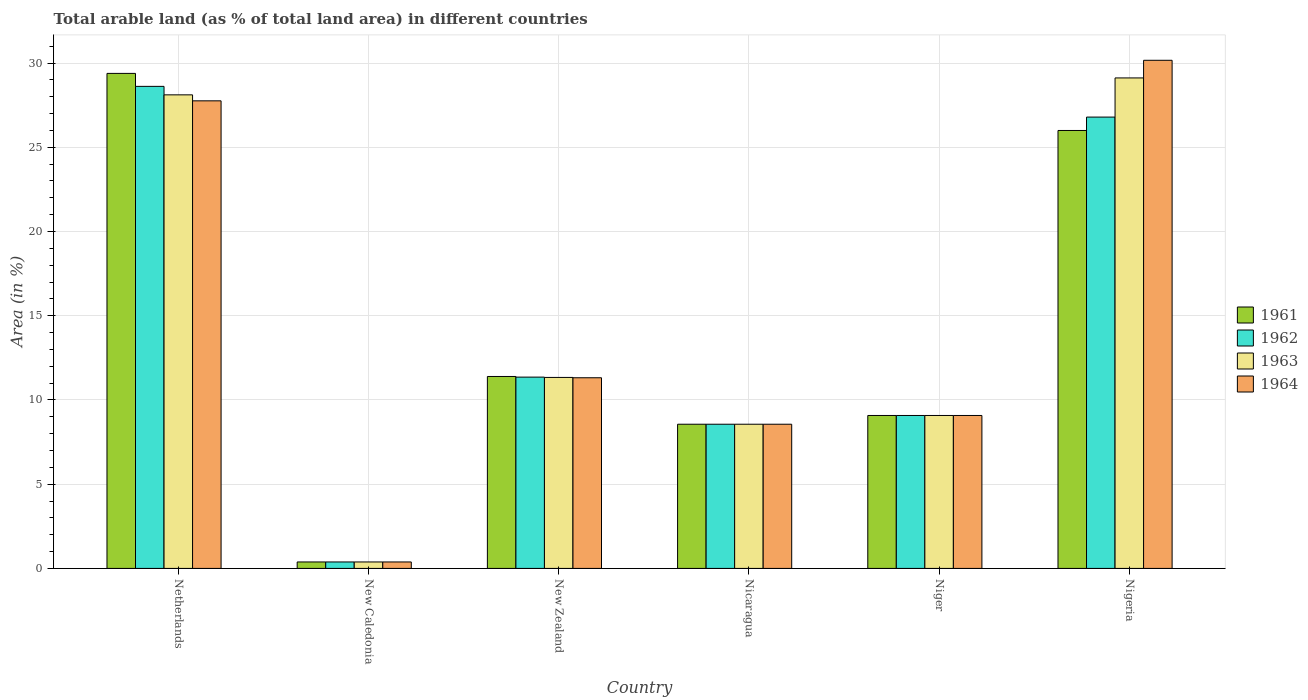How many different coloured bars are there?
Provide a succinct answer. 4. Are the number of bars per tick equal to the number of legend labels?
Your answer should be compact. Yes. Are the number of bars on each tick of the X-axis equal?
Offer a very short reply. Yes. How many bars are there on the 2nd tick from the left?
Offer a very short reply. 4. What is the label of the 6th group of bars from the left?
Your answer should be compact. Nigeria. What is the percentage of arable land in 1964 in New Zealand?
Ensure brevity in your answer.  11.32. Across all countries, what is the maximum percentage of arable land in 1961?
Offer a very short reply. 29.38. Across all countries, what is the minimum percentage of arable land in 1964?
Keep it short and to the point. 0.38. In which country was the percentage of arable land in 1963 maximum?
Offer a very short reply. Nigeria. In which country was the percentage of arable land in 1961 minimum?
Offer a very short reply. New Caledonia. What is the total percentage of arable land in 1963 in the graph?
Keep it short and to the point. 86.58. What is the difference between the percentage of arable land in 1964 in Nicaragua and that in Niger?
Your answer should be very brief. -0.52. What is the difference between the percentage of arable land in 1962 in Niger and the percentage of arable land in 1964 in New Caledonia?
Your answer should be very brief. 8.69. What is the average percentage of arable land in 1963 per country?
Your answer should be compact. 14.43. In how many countries, is the percentage of arable land in 1964 greater than 17 %?
Provide a short and direct response. 2. What is the ratio of the percentage of arable land in 1962 in Nicaragua to that in Nigeria?
Keep it short and to the point. 0.32. What is the difference between the highest and the second highest percentage of arable land in 1963?
Provide a short and direct response. -16.77. What is the difference between the highest and the lowest percentage of arable land in 1964?
Provide a succinct answer. 29.78. In how many countries, is the percentage of arable land in 1961 greater than the average percentage of arable land in 1961 taken over all countries?
Your response must be concise. 2. Is it the case that in every country, the sum of the percentage of arable land in 1962 and percentage of arable land in 1963 is greater than the sum of percentage of arable land in 1964 and percentage of arable land in 1961?
Offer a terse response. No. What does the 2nd bar from the right in Netherlands represents?
Provide a short and direct response. 1963. How many bars are there?
Provide a short and direct response. 24. Are all the bars in the graph horizontal?
Provide a short and direct response. No. How many countries are there in the graph?
Give a very brief answer. 6. Does the graph contain any zero values?
Offer a terse response. No. Where does the legend appear in the graph?
Ensure brevity in your answer.  Center right. What is the title of the graph?
Your response must be concise. Total arable land (as % of total land area) in different countries. Does "2011" appear as one of the legend labels in the graph?
Your answer should be compact. No. What is the label or title of the X-axis?
Make the answer very short. Country. What is the label or title of the Y-axis?
Your answer should be compact. Area (in %). What is the Area (in %) of 1961 in Netherlands?
Offer a very short reply. 29.38. What is the Area (in %) of 1962 in Netherlands?
Keep it short and to the point. 28.61. What is the Area (in %) in 1963 in Netherlands?
Your answer should be very brief. 28.11. What is the Area (in %) of 1964 in Netherlands?
Offer a terse response. 27.75. What is the Area (in %) in 1961 in New Caledonia?
Offer a terse response. 0.38. What is the Area (in %) in 1962 in New Caledonia?
Your answer should be very brief. 0.38. What is the Area (in %) of 1963 in New Caledonia?
Provide a short and direct response. 0.38. What is the Area (in %) of 1964 in New Caledonia?
Ensure brevity in your answer.  0.38. What is the Area (in %) of 1961 in New Zealand?
Give a very brief answer. 11.39. What is the Area (in %) in 1962 in New Zealand?
Keep it short and to the point. 11.36. What is the Area (in %) of 1963 in New Zealand?
Make the answer very short. 11.34. What is the Area (in %) of 1964 in New Zealand?
Your answer should be very brief. 11.32. What is the Area (in %) in 1961 in Nicaragua?
Offer a very short reply. 8.56. What is the Area (in %) of 1962 in Nicaragua?
Provide a succinct answer. 8.56. What is the Area (in %) in 1963 in Nicaragua?
Ensure brevity in your answer.  8.56. What is the Area (in %) in 1964 in Nicaragua?
Offer a very short reply. 8.56. What is the Area (in %) of 1961 in Niger?
Offer a terse response. 9.08. What is the Area (in %) of 1962 in Niger?
Make the answer very short. 9.08. What is the Area (in %) in 1963 in Niger?
Offer a terse response. 9.08. What is the Area (in %) of 1964 in Niger?
Give a very brief answer. 9.08. What is the Area (in %) of 1961 in Nigeria?
Your answer should be very brief. 26. What is the Area (in %) in 1962 in Nigeria?
Provide a short and direct response. 26.79. What is the Area (in %) in 1963 in Nigeria?
Offer a very short reply. 29.11. What is the Area (in %) in 1964 in Nigeria?
Provide a short and direct response. 30.16. Across all countries, what is the maximum Area (in %) of 1961?
Offer a terse response. 29.38. Across all countries, what is the maximum Area (in %) in 1962?
Your answer should be compact. 28.61. Across all countries, what is the maximum Area (in %) of 1963?
Provide a succinct answer. 29.11. Across all countries, what is the maximum Area (in %) in 1964?
Make the answer very short. 30.16. Across all countries, what is the minimum Area (in %) in 1961?
Offer a terse response. 0.38. Across all countries, what is the minimum Area (in %) of 1962?
Offer a very short reply. 0.38. Across all countries, what is the minimum Area (in %) of 1963?
Your answer should be compact. 0.38. Across all countries, what is the minimum Area (in %) of 1964?
Your response must be concise. 0.38. What is the total Area (in %) of 1961 in the graph?
Ensure brevity in your answer.  84.79. What is the total Area (in %) in 1962 in the graph?
Keep it short and to the point. 84.78. What is the total Area (in %) in 1963 in the graph?
Offer a terse response. 86.58. What is the total Area (in %) of 1964 in the graph?
Ensure brevity in your answer.  87.25. What is the difference between the Area (in %) of 1961 in Netherlands and that in New Caledonia?
Keep it short and to the point. 29. What is the difference between the Area (in %) in 1962 in Netherlands and that in New Caledonia?
Offer a very short reply. 28.23. What is the difference between the Area (in %) in 1963 in Netherlands and that in New Caledonia?
Give a very brief answer. 27.73. What is the difference between the Area (in %) of 1964 in Netherlands and that in New Caledonia?
Your answer should be compact. 27.37. What is the difference between the Area (in %) in 1961 in Netherlands and that in New Zealand?
Make the answer very short. 17.99. What is the difference between the Area (in %) of 1962 in Netherlands and that in New Zealand?
Provide a short and direct response. 17.26. What is the difference between the Area (in %) of 1963 in Netherlands and that in New Zealand?
Ensure brevity in your answer.  16.77. What is the difference between the Area (in %) in 1964 in Netherlands and that in New Zealand?
Make the answer very short. 16.44. What is the difference between the Area (in %) in 1961 in Netherlands and that in Nicaragua?
Your response must be concise. 20.82. What is the difference between the Area (in %) of 1962 in Netherlands and that in Nicaragua?
Your answer should be compact. 20.05. What is the difference between the Area (in %) of 1963 in Netherlands and that in Nicaragua?
Make the answer very short. 19.55. What is the difference between the Area (in %) in 1964 in Netherlands and that in Nicaragua?
Make the answer very short. 19.2. What is the difference between the Area (in %) in 1961 in Netherlands and that in Niger?
Offer a very short reply. 20.31. What is the difference between the Area (in %) of 1962 in Netherlands and that in Niger?
Your response must be concise. 19.54. What is the difference between the Area (in %) of 1963 in Netherlands and that in Niger?
Offer a terse response. 19.03. What is the difference between the Area (in %) of 1964 in Netherlands and that in Niger?
Give a very brief answer. 18.68. What is the difference between the Area (in %) of 1961 in Netherlands and that in Nigeria?
Give a very brief answer. 3.39. What is the difference between the Area (in %) of 1962 in Netherlands and that in Nigeria?
Make the answer very short. 1.82. What is the difference between the Area (in %) of 1963 in Netherlands and that in Nigeria?
Offer a terse response. -1. What is the difference between the Area (in %) in 1964 in Netherlands and that in Nigeria?
Your answer should be compact. -2.41. What is the difference between the Area (in %) of 1961 in New Caledonia and that in New Zealand?
Offer a very short reply. -11.01. What is the difference between the Area (in %) in 1962 in New Caledonia and that in New Zealand?
Provide a short and direct response. -10.97. What is the difference between the Area (in %) in 1963 in New Caledonia and that in New Zealand?
Make the answer very short. -10.95. What is the difference between the Area (in %) in 1964 in New Caledonia and that in New Zealand?
Give a very brief answer. -10.93. What is the difference between the Area (in %) of 1961 in New Caledonia and that in Nicaragua?
Ensure brevity in your answer.  -8.18. What is the difference between the Area (in %) in 1962 in New Caledonia and that in Nicaragua?
Your response must be concise. -8.18. What is the difference between the Area (in %) of 1963 in New Caledonia and that in Nicaragua?
Keep it short and to the point. -8.18. What is the difference between the Area (in %) in 1964 in New Caledonia and that in Nicaragua?
Make the answer very short. -8.18. What is the difference between the Area (in %) of 1961 in New Caledonia and that in Niger?
Offer a terse response. -8.7. What is the difference between the Area (in %) in 1962 in New Caledonia and that in Niger?
Your response must be concise. -8.7. What is the difference between the Area (in %) in 1963 in New Caledonia and that in Niger?
Keep it short and to the point. -8.7. What is the difference between the Area (in %) in 1964 in New Caledonia and that in Niger?
Offer a terse response. -8.7. What is the difference between the Area (in %) in 1961 in New Caledonia and that in Nigeria?
Your response must be concise. -25.61. What is the difference between the Area (in %) of 1962 in New Caledonia and that in Nigeria?
Keep it short and to the point. -26.41. What is the difference between the Area (in %) in 1963 in New Caledonia and that in Nigeria?
Your answer should be very brief. -28.73. What is the difference between the Area (in %) in 1964 in New Caledonia and that in Nigeria?
Your response must be concise. -29.78. What is the difference between the Area (in %) of 1961 in New Zealand and that in Nicaragua?
Offer a terse response. 2.83. What is the difference between the Area (in %) of 1962 in New Zealand and that in Nicaragua?
Keep it short and to the point. 2.8. What is the difference between the Area (in %) of 1963 in New Zealand and that in Nicaragua?
Provide a succinct answer. 2.78. What is the difference between the Area (in %) in 1964 in New Zealand and that in Nicaragua?
Offer a terse response. 2.76. What is the difference between the Area (in %) of 1961 in New Zealand and that in Niger?
Your response must be concise. 2.32. What is the difference between the Area (in %) of 1962 in New Zealand and that in Niger?
Keep it short and to the point. 2.28. What is the difference between the Area (in %) of 1963 in New Zealand and that in Niger?
Provide a short and direct response. 2.26. What is the difference between the Area (in %) of 1964 in New Zealand and that in Niger?
Offer a terse response. 2.24. What is the difference between the Area (in %) in 1961 in New Zealand and that in Nigeria?
Give a very brief answer. -14.6. What is the difference between the Area (in %) in 1962 in New Zealand and that in Nigeria?
Offer a very short reply. -15.44. What is the difference between the Area (in %) of 1963 in New Zealand and that in Nigeria?
Make the answer very short. -17.78. What is the difference between the Area (in %) in 1964 in New Zealand and that in Nigeria?
Your response must be concise. -18.84. What is the difference between the Area (in %) of 1961 in Nicaragua and that in Niger?
Your answer should be compact. -0.52. What is the difference between the Area (in %) in 1962 in Nicaragua and that in Niger?
Provide a short and direct response. -0.52. What is the difference between the Area (in %) of 1963 in Nicaragua and that in Niger?
Give a very brief answer. -0.52. What is the difference between the Area (in %) in 1964 in Nicaragua and that in Niger?
Offer a terse response. -0.52. What is the difference between the Area (in %) in 1961 in Nicaragua and that in Nigeria?
Give a very brief answer. -17.44. What is the difference between the Area (in %) of 1962 in Nicaragua and that in Nigeria?
Offer a terse response. -18.23. What is the difference between the Area (in %) of 1963 in Nicaragua and that in Nigeria?
Ensure brevity in your answer.  -20.56. What is the difference between the Area (in %) in 1964 in Nicaragua and that in Nigeria?
Your answer should be very brief. -21.6. What is the difference between the Area (in %) of 1961 in Niger and that in Nigeria?
Your answer should be compact. -16.92. What is the difference between the Area (in %) in 1962 in Niger and that in Nigeria?
Give a very brief answer. -17.71. What is the difference between the Area (in %) in 1963 in Niger and that in Nigeria?
Your answer should be compact. -20.04. What is the difference between the Area (in %) in 1964 in Niger and that in Nigeria?
Provide a succinct answer. -21.08. What is the difference between the Area (in %) in 1961 in Netherlands and the Area (in %) in 1962 in New Caledonia?
Provide a short and direct response. 29. What is the difference between the Area (in %) in 1961 in Netherlands and the Area (in %) in 1963 in New Caledonia?
Provide a short and direct response. 29. What is the difference between the Area (in %) in 1961 in Netherlands and the Area (in %) in 1964 in New Caledonia?
Your answer should be compact. 29. What is the difference between the Area (in %) of 1962 in Netherlands and the Area (in %) of 1963 in New Caledonia?
Your response must be concise. 28.23. What is the difference between the Area (in %) of 1962 in Netherlands and the Area (in %) of 1964 in New Caledonia?
Ensure brevity in your answer.  28.23. What is the difference between the Area (in %) in 1963 in Netherlands and the Area (in %) in 1964 in New Caledonia?
Provide a succinct answer. 27.73. What is the difference between the Area (in %) in 1961 in Netherlands and the Area (in %) in 1962 in New Zealand?
Your answer should be very brief. 18.03. What is the difference between the Area (in %) in 1961 in Netherlands and the Area (in %) in 1963 in New Zealand?
Offer a terse response. 18.05. What is the difference between the Area (in %) of 1961 in Netherlands and the Area (in %) of 1964 in New Zealand?
Provide a succinct answer. 18.07. What is the difference between the Area (in %) in 1962 in Netherlands and the Area (in %) in 1963 in New Zealand?
Offer a very short reply. 17.28. What is the difference between the Area (in %) of 1962 in Netherlands and the Area (in %) of 1964 in New Zealand?
Give a very brief answer. 17.3. What is the difference between the Area (in %) of 1963 in Netherlands and the Area (in %) of 1964 in New Zealand?
Make the answer very short. 16.79. What is the difference between the Area (in %) of 1961 in Netherlands and the Area (in %) of 1962 in Nicaragua?
Your answer should be very brief. 20.82. What is the difference between the Area (in %) in 1961 in Netherlands and the Area (in %) in 1963 in Nicaragua?
Make the answer very short. 20.82. What is the difference between the Area (in %) in 1961 in Netherlands and the Area (in %) in 1964 in Nicaragua?
Keep it short and to the point. 20.82. What is the difference between the Area (in %) of 1962 in Netherlands and the Area (in %) of 1963 in Nicaragua?
Ensure brevity in your answer.  20.05. What is the difference between the Area (in %) in 1962 in Netherlands and the Area (in %) in 1964 in Nicaragua?
Ensure brevity in your answer.  20.05. What is the difference between the Area (in %) of 1963 in Netherlands and the Area (in %) of 1964 in Nicaragua?
Offer a terse response. 19.55. What is the difference between the Area (in %) of 1961 in Netherlands and the Area (in %) of 1962 in Niger?
Provide a succinct answer. 20.31. What is the difference between the Area (in %) in 1961 in Netherlands and the Area (in %) in 1963 in Niger?
Offer a very short reply. 20.31. What is the difference between the Area (in %) of 1961 in Netherlands and the Area (in %) of 1964 in Niger?
Provide a succinct answer. 20.31. What is the difference between the Area (in %) in 1962 in Netherlands and the Area (in %) in 1963 in Niger?
Offer a terse response. 19.54. What is the difference between the Area (in %) of 1962 in Netherlands and the Area (in %) of 1964 in Niger?
Provide a succinct answer. 19.54. What is the difference between the Area (in %) in 1963 in Netherlands and the Area (in %) in 1964 in Niger?
Your response must be concise. 19.03. What is the difference between the Area (in %) of 1961 in Netherlands and the Area (in %) of 1962 in Nigeria?
Offer a terse response. 2.59. What is the difference between the Area (in %) of 1961 in Netherlands and the Area (in %) of 1963 in Nigeria?
Offer a terse response. 0.27. What is the difference between the Area (in %) in 1961 in Netherlands and the Area (in %) in 1964 in Nigeria?
Your response must be concise. -0.78. What is the difference between the Area (in %) of 1962 in Netherlands and the Area (in %) of 1963 in Nigeria?
Provide a short and direct response. -0.5. What is the difference between the Area (in %) in 1962 in Netherlands and the Area (in %) in 1964 in Nigeria?
Ensure brevity in your answer.  -1.55. What is the difference between the Area (in %) of 1963 in Netherlands and the Area (in %) of 1964 in Nigeria?
Your answer should be compact. -2.05. What is the difference between the Area (in %) of 1961 in New Caledonia and the Area (in %) of 1962 in New Zealand?
Your answer should be very brief. -10.97. What is the difference between the Area (in %) of 1961 in New Caledonia and the Area (in %) of 1963 in New Zealand?
Your answer should be very brief. -10.95. What is the difference between the Area (in %) in 1961 in New Caledonia and the Area (in %) in 1964 in New Zealand?
Provide a short and direct response. -10.93. What is the difference between the Area (in %) of 1962 in New Caledonia and the Area (in %) of 1963 in New Zealand?
Your response must be concise. -10.95. What is the difference between the Area (in %) in 1962 in New Caledonia and the Area (in %) in 1964 in New Zealand?
Keep it short and to the point. -10.93. What is the difference between the Area (in %) in 1963 in New Caledonia and the Area (in %) in 1964 in New Zealand?
Make the answer very short. -10.93. What is the difference between the Area (in %) of 1961 in New Caledonia and the Area (in %) of 1962 in Nicaragua?
Keep it short and to the point. -8.18. What is the difference between the Area (in %) in 1961 in New Caledonia and the Area (in %) in 1963 in Nicaragua?
Ensure brevity in your answer.  -8.18. What is the difference between the Area (in %) of 1961 in New Caledonia and the Area (in %) of 1964 in Nicaragua?
Provide a short and direct response. -8.18. What is the difference between the Area (in %) of 1962 in New Caledonia and the Area (in %) of 1963 in Nicaragua?
Ensure brevity in your answer.  -8.18. What is the difference between the Area (in %) of 1962 in New Caledonia and the Area (in %) of 1964 in Nicaragua?
Ensure brevity in your answer.  -8.18. What is the difference between the Area (in %) of 1963 in New Caledonia and the Area (in %) of 1964 in Nicaragua?
Keep it short and to the point. -8.18. What is the difference between the Area (in %) of 1961 in New Caledonia and the Area (in %) of 1962 in Niger?
Ensure brevity in your answer.  -8.7. What is the difference between the Area (in %) in 1961 in New Caledonia and the Area (in %) in 1963 in Niger?
Keep it short and to the point. -8.7. What is the difference between the Area (in %) in 1961 in New Caledonia and the Area (in %) in 1964 in Niger?
Offer a terse response. -8.7. What is the difference between the Area (in %) in 1962 in New Caledonia and the Area (in %) in 1963 in Niger?
Offer a terse response. -8.7. What is the difference between the Area (in %) in 1962 in New Caledonia and the Area (in %) in 1964 in Niger?
Make the answer very short. -8.7. What is the difference between the Area (in %) of 1963 in New Caledonia and the Area (in %) of 1964 in Niger?
Provide a short and direct response. -8.7. What is the difference between the Area (in %) of 1961 in New Caledonia and the Area (in %) of 1962 in Nigeria?
Provide a short and direct response. -26.41. What is the difference between the Area (in %) in 1961 in New Caledonia and the Area (in %) in 1963 in Nigeria?
Give a very brief answer. -28.73. What is the difference between the Area (in %) of 1961 in New Caledonia and the Area (in %) of 1964 in Nigeria?
Make the answer very short. -29.78. What is the difference between the Area (in %) in 1962 in New Caledonia and the Area (in %) in 1963 in Nigeria?
Offer a very short reply. -28.73. What is the difference between the Area (in %) of 1962 in New Caledonia and the Area (in %) of 1964 in Nigeria?
Your answer should be very brief. -29.78. What is the difference between the Area (in %) in 1963 in New Caledonia and the Area (in %) in 1964 in Nigeria?
Your answer should be compact. -29.78. What is the difference between the Area (in %) in 1961 in New Zealand and the Area (in %) in 1962 in Nicaragua?
Give a very brief answer. 2.83. What is the difference between the Area (in %) in 1961 in New Zealand and the Area (in %) in 1963 in Nicaragua?
Offer a terse response. 2.83. What is the difference between the Area (in %) of 1961 in New Zealand and the Area (in %) of 1964 in Nicaragua?
Your answer should be compact. 2.83. What is the difference between the Area (in %) of 1962 in New Zealand and the Area (in %) of 1963 in Nicaragua?
Your response must be concise. 2.8. What is the difference between the Area (in %) in 1962 in New Zealand and the Area (in %) in 1964 in Nicaragua?
Your response must be concise. 2.8. What is the difference between the Area (in %) in 1963 in New Zealand and the Area (in %) in 1964 in Nicaragua?
Provide a short and direct response. 2.78. What is the difference between the Area (in %) in 1961 in New Zealand and the Area (in %) in 1962 in Niger?
Offer a very short reply. 2.32. What is the difference between the Area (in %) of 1961 in New Zealand and the Area (in %) of 1963 in Niger?
Offer a very short reply. 2.32. What is the difference between the Area (in %) of 1961 in New Zealand and the Area (in %) of 1964 in Niger?
Your answer should be compact. 2.32. What is the difference between the Area (in %) of 1962 in New Zealand and the Area (in %) of 1963 in Niger?
Make the answer very short. 2.28. What is the difference between the Area (in %) of 1962 in New Zealand and the Area (in %) of 1964 in Niger?
Provide a succinct answer. 2.28. What is the difference between the Area (in %) in 1963 in New Zealand and the Area (in %) in 1964 in Niger?
Ensure brevity in your answer.  2.26. What is the difference between the Area (in %) of 1961 in New Zealand and the Area (in %) of 1962 in Nigeria?
Offer a terse response. -15.4. What is the difference between the Area (in %) in 1961 in New Zealand and the Area (in %) in 1963 in Nigeria?
Provide a short and direct response. -17.72. What is the difference between the Area (in %) of 1961 in New Zealand and the Area (in %) of 1964 in Nigeria?
Offer a very short reply. -18.77. What is the difference between the Area (in %) in 1962 in New Zealand and the Area (in %) in 1963 in Nigeria?
Provide a succinct answer. -17.76. What is the difference between the Area (in %) in 1962 in New Zealand and the Area (in %) in 1964 in Nigeria?
Your response must be concise. -18.81. What is the difference between the Area (in %) in 1963 in New Zealand and the Area (in %) in 1964 in Nigeria?
Keep it short and to the point. -18.83. What is the difference between the Area (in %) in 1961 in Nicaragua and the Area (in %) in 1962 in Niger?
Provide a short and direct response. -0.52. What is the difference between the Area (in %) of 1961 in Nicaragua and the Area (in %) of 1963 in Niger?
Your answer should be compact. -0.52. What is the difference between the Area (in %) in 1961 in Nicaragua and the Area (in %) in 1964 in Niger?
Provide a succinct answer. -0.52. What is the difference between the Area (in %) in 1962 in Nicaragua and the Area (in %) in 1963 in Niger?
Ensure brevity in your answer.  -0.52. What is the difference between the Area (in %) of 1962 in Nicaragua and the Area (in %) of 1964 in Niger?
Your answer should be compact. -0.52. What is the difference between the Area (in %) of 1963 in Nicaragua and the Area (in %) of 1964 in Niger?
Give a very brief answer. -0.52. What is the difference between the Area (in %) in 1961 in Nicaragua and the Area (in %) in 1962 in Nigeria?
Ensure brevity in your answer.  -18.23. What is the difference between the Area (in %) of 1961 in Nicaragua and the Area (in %) of 1963 in Nigeria?
Make the answer very short. -20.56. What is the difference between the Area (in %) of 1961 in Nicaragua and the Area (in %) of 1964 in Nigeria?
Give a very brief answer. -21.6. What is the difference between the Area (in %) of 1962 in Nicaragua and the Area (in %) of 1963 in Nigeria?
Your response must be concise. -20.56. What is the difference between the Area (in %) of 1962 in Nicaragua and the Area (in %) of 1964 in Nigeria?
Make the answer very short. -21.6. What is the difference between the Area (in %) of 1963 in Nicaragua and the Area (in %) of 1964 in Nigeria?
Provide a short and direct response. -21.6. What is the difference between the Area (in %) of 1961 in Niger and the Area (in %) of 1962 in Nigeria?
Provide a short and direct response. -17.71. What is the difference between the Area (in %) in 1961 in Niger and the Area (in %) in 1963 in Nigeria?
Offer a terse response. -20.04. What is the difference between the Area (in %) of 1961 in Niger and the Area (in %) of 1964 in Nigeria?
Provide a short and direct response. -21.08. What is the difference between the Area (in %) of 1962 in Niger and the Area (in %) of 1963 in Nigeria?
Your response must be concise. -20.04. What is the difference between the Area (in %) in 1962 in Niger and the Area (in %) in 1964 in Nigeria?
Your answer should be compact. -21.08. What is the difference between the Area (in %) in 1963 in Niger and the Area (in %) in 1964 in Nigeria?
Ensure brevity in your answer.  -21.08. What is the average Area (in %) in 1961 per country?
Offer a terse response. 14.13. What is the average Area (in %) of 1962 per country?
Offer a terse response. 14.13. What is the average Area (in %) in 1963 per country?
Your answer should be very brief. 14.43. What is the average Area (in %) in 1964 per country?
Keep it short and to the point. 14.54. What is the difference between the Area (in %) in 1961 and Area (in %) in 1962 in Netherlands?
Your answer should be compact. 0.77. What is the difference between the Area (in %) of 1961 and Area (in %) of 1963 in Netherlands?
Provide a short and direct response. 1.27. What is the difference between the Area (in %) of 1961 and Area (in %) of 1964 in Netherlands?
Offer a terse response. 1.63. What is the difference between the Area (in %) in 1962 and Area (in %) in 1963 in Netherlands?
Make the answer very short. 0.5. What is the difference between the Area (in %) in 1962 and Area (in %) in 1964 in Netherlands?
Your response must be concise. 0.86. What is the difference between the Area (in %) in 1963 and Area (in %) in 1964 in Netherlands?
Provide a short and direct response. 0.36. What is the difference between the Area (in %) of 1963 and Area (in %) of 1964 in New Caledonia?
Make the answer very short. 0. What is the difference between the Area (in %) in 1961 and Area (in %) in 1962 in New Zealand?
Your answer should be compact. 0.04. What is the difference between the Area (in %) in 1961 and Area (in %) in 1963 in New Zealand?
Your answer should be compact. 0.06. What is the difference between the Area (in %) of 1961 and Area (in %) of 1964 in New Zealand?
Offer a terse response. 0.08. What is the difference between the Area (in %) of 1962 and Area (in %) of 1963 in New Zealand?
Your answer should be very brief. 0.02. What is the difference between the Area (in %) in 1962 and Area (in %) in 1964 in New Zealand?
Provide a succinct answer. 0.04. What is the difference between the Area (in %) of 1963 and Area (in %) of 1964 in New Zealand?
Provide a short and direct response. 0.02. What is the difference between the Area (in %) of 1961 and Area (in %) of 1962 in Nicaragua?
Your answer should be very brief. 0. What is the difference between the Area (in %) of 1961 and Area (in %) of 1963 in Nicaragua?
Offer a terse response. 0. What is the difference between the Area (in %) of 1962 and Area (in %) of 1963 in Nicaragua?
Keep it short and to the point. 0. What is the difference between the Area (in %) in 1962 and Area (in %) in 1964 in Nicaragua?
Your answer should be compact. 0. What is the difference between the Area (in %) in 1963 and Area (in %) in 1964 in Nicaragua?
Offer a very short reply. 0. What is the difference between the Area (in %) in 1961 and Area (in %) in 1962 in Niger?
Provide a short and direct response. 0. What is the difference between the Area (in %) in 1961 and Area (in %) in 1963 in Niger?
Your answer should be very brief. 0. What is the difference between the Area (in %) in 1962 and Area (in %) in 1963 in Niger?
Make the answer very short. 0. What is the difference between the Area (in %) of 1963 and Area (in %) of 1964 in Niger?
Give a very brief answer. 0. What is the difference between the Area (in %) in 1961 and Area (in %) in 1962 in Nigeria?
Your response must be concise. -0.79. What is the difference between the Area (in %) of 1961 and Area (in %) of 1963 in Nigeria?
Make the answer very short. -3.12. What is the difference between the Area (in %) in 1961 and Area (in %) in 1964 in Nigeria?
Offer a very short reply. -4.17. What is the difference between the Area (in %) in 1962 and Area (in %) in 1963 in Nigeria?
Ensure brevity in your answer.  -2.32. What is the difference between the Area (in %) in 1962 and Area (in %) in 1964 in Nigeria?
Your answer should be very brief. -3.37. What is the difference between the Area (in %) in 1963 and Area (in %) in 1964 in Nigeria?
Provide a succinct answer. -1.05. What is the ratio of the Area (in %) in 1961 in Netherlands to that in New Caledonia?
Offer a very short reply. 76.73. What is the ratio of the Area (in %) of 1962 in Netherlands to that in New Caledonia?
Ensure brevity in your answer.  74.72. What is the ratio of the Area (in %) in 1963 in Netherlands to that in New Caledonia?
Give a very brief answer. 73.41. What is the ratio of the Area (in %) in 1964 in Netherlands to that in New Caledonia?
Give a very brief answer. 72.48. What is the ratio of the Area (in %) in 1961 in Netherlands to that in New Zealand?
Provide a succinct answer. 2.58. What is the ratio of the Area (in %) of 1962 in Netherlands to that in New Zealand?
Provide a succinct answer. 2.52. What is the ratio of the Area (in %) in 1963 in Netherlands to that in New Zealand?
Offer a very short reply. 2.48. What is the ratio of the Area (in %) of 1964 in Netherlands to that in New Zealand?
Give a very brief answer. 2.45. What is the ratio of the Area (in %) of 1961 in Netherlands to that in Nicaragua?
Provide a succinct answer. 3.43. What is the ratio of the Area (in %) in 1962 in Netherlands to that in Nicaragua?
Your response must be concise. 3.34. What is the ratio of the Area (in %) in 1963 in Netherlands to that in Nicaragua?
Ensure brevity in your answer.  3.28. What is the ratio of the Area (in %) in 1964 in Netherlands to that in Nicaragua?
Make the answer very short. 3.24. What is the ratio of the Area (in %) in 1961 in Netherlands to that in Niger?
Your response must be concise. 3.24. What is the ratio of the Area (in %) of 1962 in Netherlands to that in Niger?
Give a very brief answer. 3.15. What is the ratio of the Area (in %) in 1963 in Netherlands to that in Niger?
Provide a short and direct response. 3.1. What is the ratio of the Area (in %) in 1964 in Netherlands to that in Niger?
Your answer should be compact. 3.06. What is the ratio of the Area (in %) in 1961 in Netherlands to that in Nigeria?
Your response must be concise. 1.13. What is the ratio of the Area (in %) in 1962 in Netherlands to that in Nigeria?
Ensure brevity in your answer.  1.07. What is the ratio of the Area (in %) of 1963 in Netherlands to that in Nigeria?
Provide a short and direct response. 0.97. What is the ratio of the Area (in %) in 1964 in Netherlands to that in Nigeria?
Your response must be concise. 0.92. What is the ratio of the Area (in %) of 1961 in New Caledonia to that in New Zealand?
Offer a very short reply. 0.03. What is the ratio of the Area (in %) of 1962 in New Caledonia to that in New Zealand?
Your answer should be compact. 0.03. What is the ratio of the Area (in %) in 1963 in New Caledonia to that in New Zealand?
Your answer should be very brief. 0.03. What is the ratio of the Area (in %) of 1964 in New Caledonia to that in New Zealand?
Offer a very short reply. 0.03. What is the ratio of the Area (in %) in 1961 in New Caledonia to that in Nicaragua?
Give a very brief answer. 0.04. What is the ratio of the Area (in %) of 1962 in New Caledonia to that in Nicaragua?
Your answer should be compact. 0.04. What is the ratio of the Area (in %) of 1963 in New Caledonia to that in Nicaragua?
Provide a succinct answer. 0.04. What is the ratio of the Area (in %) in 1964 in New Caledonia to that in Nicaragua?
Your answer should be compact. 0.04. What is the ratio of the Area (in %) in 1961 in New Caledonia to that in Niger?
Ensure brevity in your answer.  0.04. What is the ratio of the Area (in %) of 1962 in New Caledonia to that in Niger?
Keep it short and to the point. 0.04. What is the ratio of the Area (in %) of 1963 in New Caledonia to that in Niger?
Your response must be concise. 0.04. What is the ratio of the Area (in %) in 1964 in New Caledonia to that in Niger?
Provide a short and direct response. 0.04. What is the ratio of the Area (in %) in 1961 in New Caledonia to that in Nigeria?
Your answer should be very brief. 0.01. What is the ratio of the Area (in %) of 1962 in New Caledonia to that in Nigeria?
Your answer should be very brief. 0.01. What is the ratio of the Area (in %) of 1963 in New Caledonia to that in Nigeria?
Make the answer very short. 0.01. What is the ratio of the Area (in %) in 1964 in New Caledonia to that in Nigeria?
Ensure brevity in your answer.  0.01. What is the ratio of the Area (in %) in 1961 in New Zealand to that in Nicaragua?
Make the answer very short. 1.33. What is the ratio of the Area (in %) in 1962 in New Zealand to that in Nicaragua?
Ensure brevity in your answer.  1.33. What is the ratio of the Area (in %) in 1963 in New Zealand to that in Nicaragua?
Your answer should be compact. 1.32. What is the ratio of the Area (in %) of 1964 in New Zealand to that in Nicaragua?
Provide a short and direct response. 1.32. What is the ratio of the Area (in %) in 1961 in New Zealand to that in Niger?
Make the answer very short. 1.26. What is the ratio of the Area (in %) of 1962 in New Zealand to that in Niger?
Your response must be concise. 1.25. What is the ratio of the Area (in %) in 1963 in New Zealand to that in Niger?
Your response must be concise. 1.25. What is the ratio of the Area (in %) in 1964 in New Zealand to that in Niger?
Your response must be concise. 1.25. What is the ratio of the Area (in %) in 1961 in New Zealand to that in Nigeria?
Offer a very short reply. 0.44. What is the ratio of the Area (in %) in 1962 in New Zealand to that in Nigeria?
Offer a terse response. 0.42. What is the ratio of the Area (in %) of 1963 in New Zealand to that in Nigeria?
Provide a short and direct response. 0.39. What is the ratio of the Area (in %) of 1964 in New Zealand to that in Nigeria?
Offer a terse response. 0.38. What is the ratio of the Area (in %) of 1961 in Nicaragua to that in Niger?
Keep it short and to the point. 0.94. What is the ratio of the Area (in %) in 1962 in Nicaragua to that in Niger?
Your answer should be compact. 0.94. What is the ratio of the Area (in %) of 1963 in Nicaragua to that in Niger?
Give a very brief answer. 0.94. What is the ratio of the Area (in %) of 1964 in Nicaragua to that in Niger?
Your answer should be very brief. 0.94. What is the ratio of the Area (in %) of 1961 in Nicaragua to that in Nigeria?
Your answer should be compact. 0.33. What is the ratio of the Area (in %) of 1962 in Nicaragua to that in Nigeria?
Make the answer very short. 0.32. What is the ratio of the Area (in %) of 1963 in Nicaragua to that in Nigeria?
Your response must be concise. 0.29. What is the ratio of the Area (in %) of 1964 in Nicaragua to that in Nigeria?
Offer a terse response. 0.28. What is the ratio of the Area (in %) of 1961 in Niger to that in Nigeria?
Your answer should be compact. 0.35. What is the ratio of the Area (in %) in 1962 in Niger to that in Nigeria?
Offer a very short reply. 0.34. What is the ratio of the Area (in %) of 1963 in Niger to that in Nigeria?
Offer a terse response. 0.31. What is the ratio of the Area (in %) of 1964 in Niger to that in Nigeria?
Offer a terse response. 0.3. What is the difference between the highest and the second highest Area (in %) in 1961?
Your answer should be compact. 3.39. What is the difference between the highest and the second highest Area (in %) in 1962?
Make the answer very short. 1.82. What is the difference between the highest and the second highest Area (in %) in 1963?
Keep it short and to the point. 1. What is the difference between the highest and the second highest Area (in %) in 1964?
Your response must be concise. 2.41. What is the difference between the highest and the lowest Area (in %) in 1961?
Your answer should be compact. 29. What is the difference between the highest and the lowest Area (in %) of 1962?
Make the answer very short. 28.23. What is the difference between the highest and the lowest Area (in %) in 1963?
Provide a succinct answer. 28.73. What is the difference between the highest and the lowest Area (in %) in 1964?
Your answer should be compact. 29.78. 